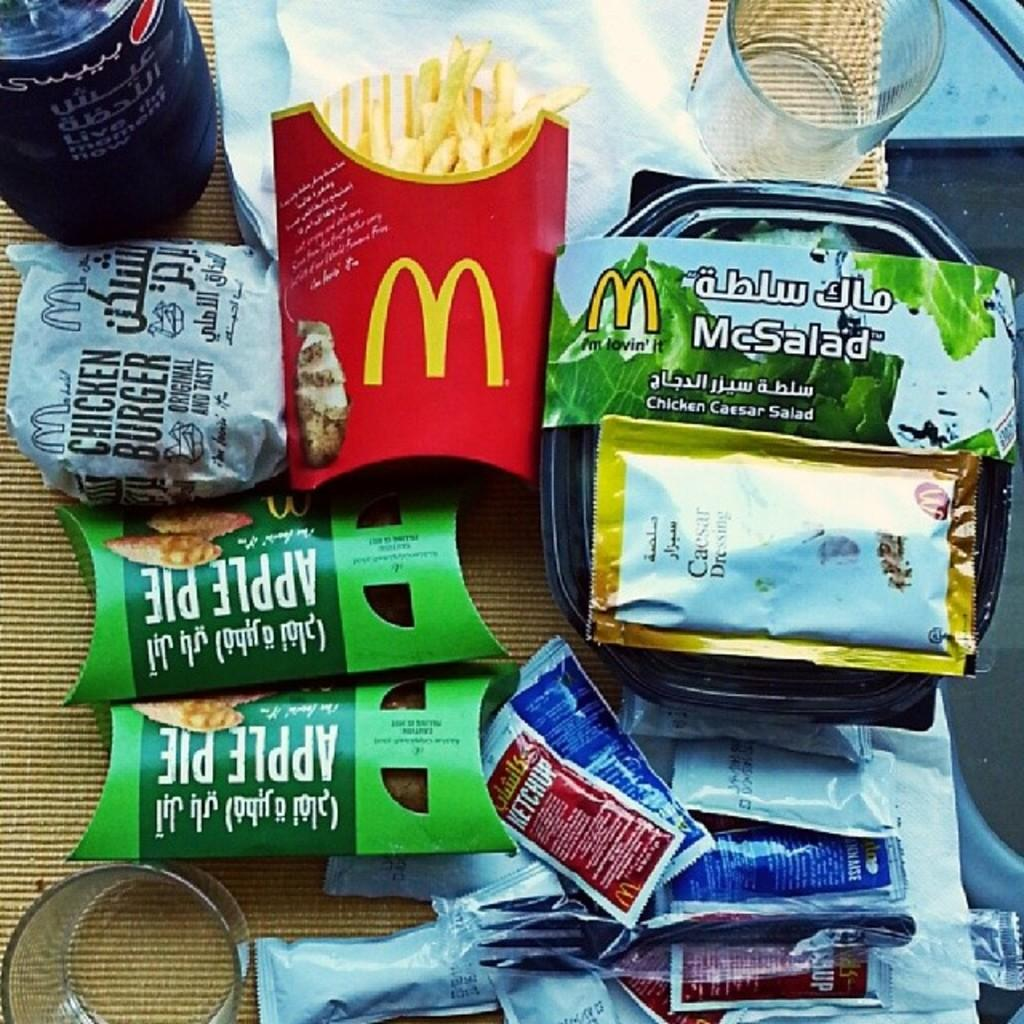What type of food can be seen in the image? There are french fries and biscuits in the image. What can be used for dipping or adding flavor to the food? There are sauce packets in the image. What is present for drinking in the image? There is a glass in the image. What can be used for cleaning or wiping in the image? There are tissues in the image. Where are all of these items located in the image? All of these items are on a table. What type of plate is being used to serve the food in the image? There is no plate visible in the image; the food items are on a table. 